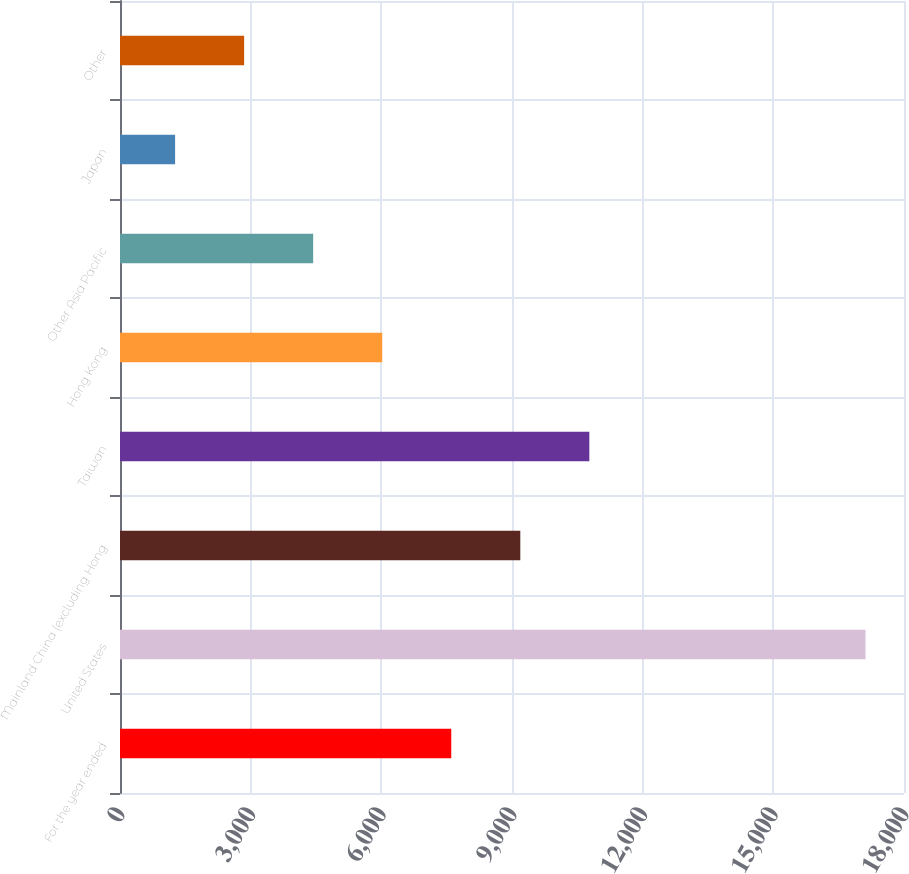Convert chart. <chart><loc_0><loc_0><loc_500><loc_500><bar_chart><fcel>For the year ended<fcel>United States<fcel>Mainland China (excluding Hong<fcel>Taiwan<fcel>Hong Kong<fcel>Other Asia Pacific<fcel>Japan<fcel>Other<nl><fcel>7605.4<fcel>17116<fcel>9190.5<fcel>10775.6<fcel>6020.3<fcel>4435.2<fcel>1265<fcel>2850.1<nl></chart> 